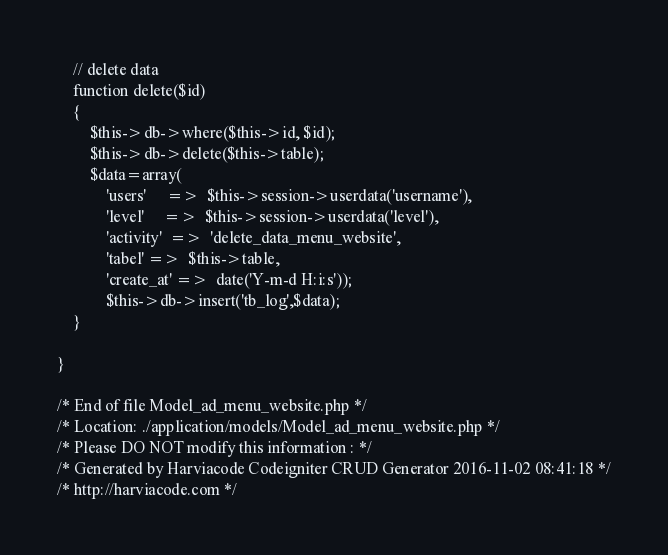Convert code to text. <code><loc_0><loc_0><loc_500><loc_500><_PHP_>
    // delete data
    function delete($id)
    {
        $this->db->where($this->id, $id);
        $this->db->delete($this->table);
        $data=array(
        	'users'		=>  $this->session->userdata('username'),
        	'level'		=>  $this->session->userdata('level'),
        	'activity'	=>  'delete_data_menu_website',
        	'tabel'	=>  $this->table,
        	'create_at'	=>  date('Y-m-d H:i:s'));
        	$this->db->insert('tb_log',$data);
    }

}

/* End of file Model_ad_menu_website.php */
/* Location: ./application/models/Model_ad_menu_website.php */
/* Please DO NOT modify this information : */
/* Generated by Harviacode Codeigniter CRUD Generator 2016-11-02 08:41:18 */
/* http://harviacode.com */</code> 